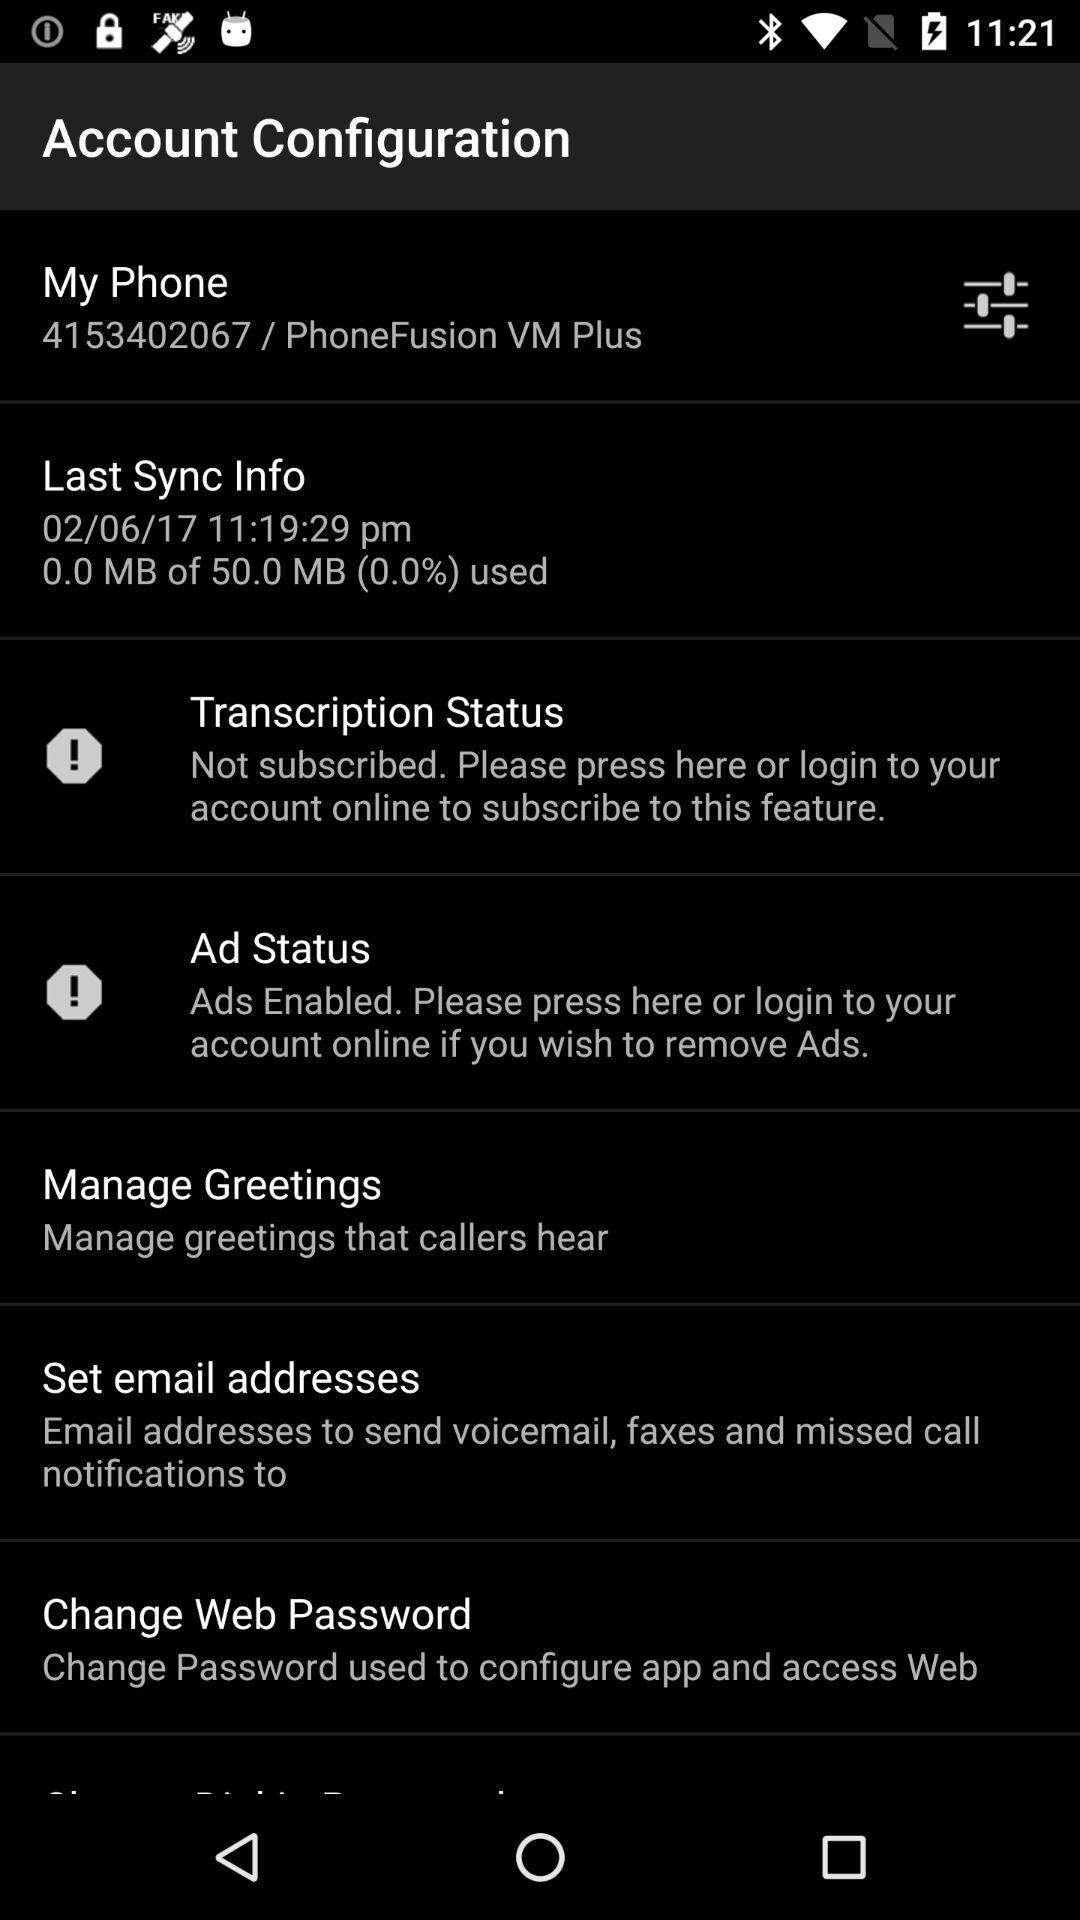Are "Ads" enabled or disabled?
Answer the question using a single word or phrase. "Ads" are enabled. 